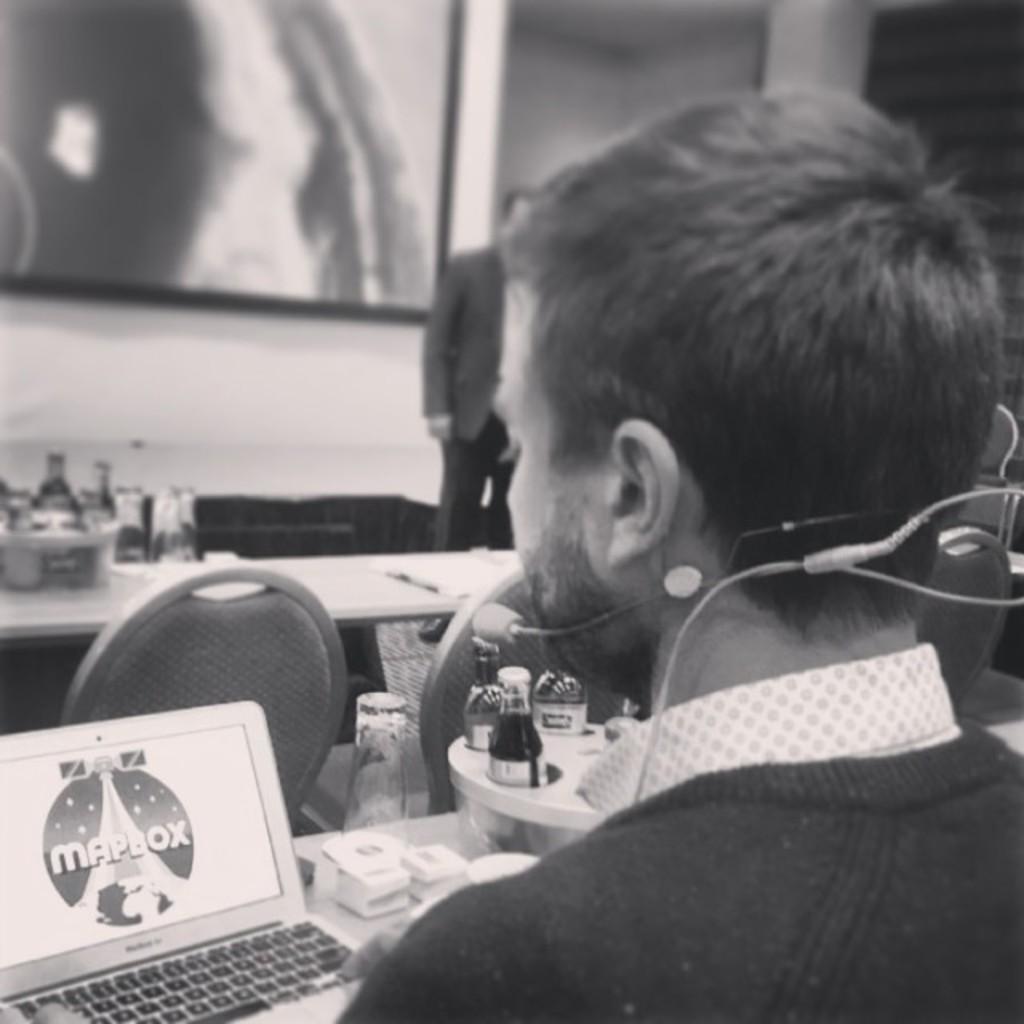Describe this image in one or two sentences. In this image I can see a man in the front and near his mouth I can see a mic. In the front of him I can see few tables, few chairs and on these tables I can see number of bottles, a laptop and few other things. In the background I can see one person is standing and on the top left side of this image I can see a frame on the wall. 